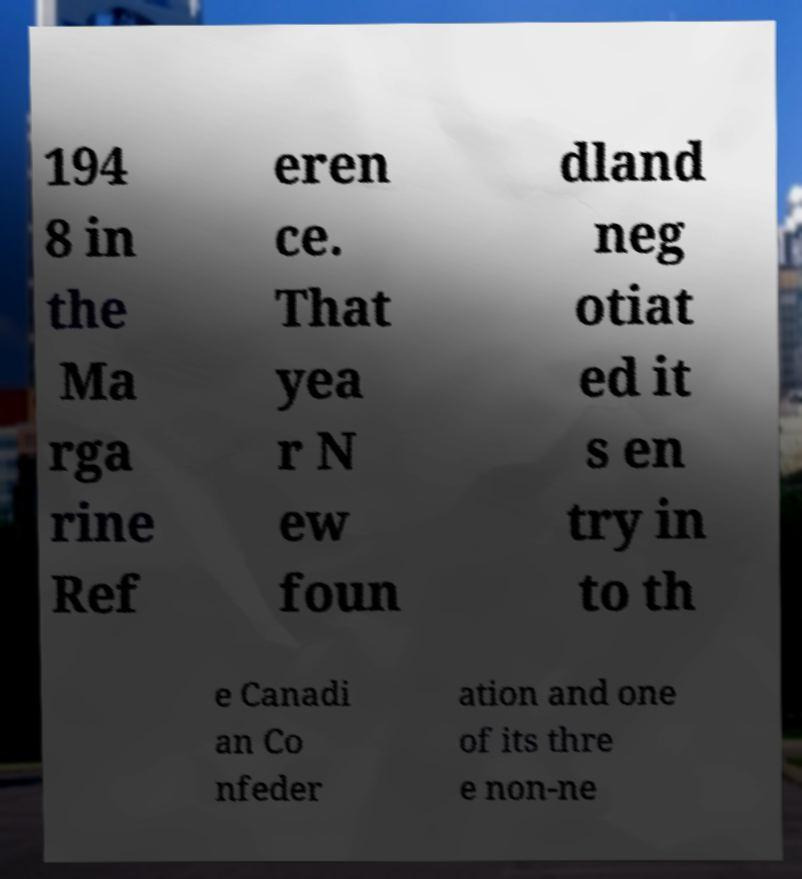For documentation purposes, I need the text within this image transcribed. Could you provide that? 194 8 in the Ma rga rine Ref eren ce. That yea r N ew foun dland neg otiat ed it s en try in to th e Canadi an Co nfeder ation and one of its thre e non-ne 